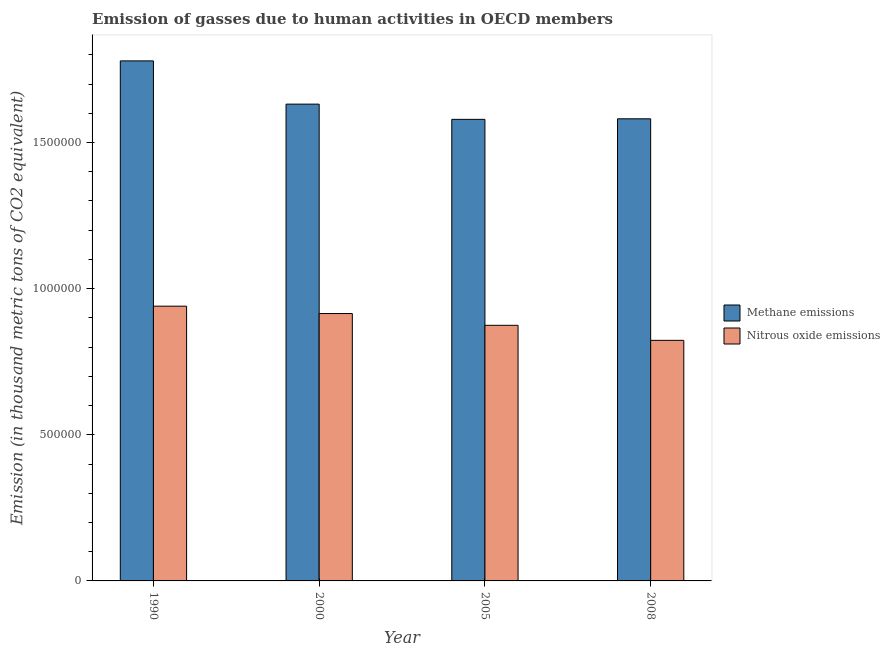How many groups of bars are there?
Provide a short and direct response. 4. Are the number of bars on each tick of the X-axis equal?
Ensure brevity in your answer.  Yes. How many bars are there on the 3rd tick from the left?
Offer a terse response. 2. How many bars are there on the 1st tick from the right?
Provide a succinct answer. 2. What is the amount of nitrous oxide emissions in 1990?
Offer a very short reply. 9.40e+05. Across all years, what is the maximum amount of nitrous oxide emissions?
Ensure brevity in your answer.  9.40e+05. Across all years, what is the minimum amount of nitrous oxide emissions?
Offer a terse response. 8.23e+05. In which year was the amount of methane emissions maximum?
Your response must be concise. 1990. In which year was the amount of methane emissions minimum?
Your answer should be compact. 2005. What is the total amount of methane emissions in the graph?
Offer a very short reply. 6.57e+06. What is the difference between the amount of nitrous oxide emissions in 1990 and that in 2008?
Your response must be concise. 1.17e+05. What is the difference between the amount of nitrous oxide emissions in 1990 and the amount of methane emissions in 2000?
Your response must be concise. 2.52e+04. What is the average amount of methane emissions per year?
Provide a succinct answer. 1.64e+06. In the year 1990, what is the difference between the amount of methane emissions and amount of nitrous oxide emissions?
Offer a terse response. 0. What is the ratio of the amount of nitrous oxide emissions in 1990 to that in 2005?
Give a very brief answer. 1.07. What is the difference between the highest and the second highest amount of nitrous oxide emissions?
Offer a terse response. 2.52e+04. What is the difference between the highest and the lowest amount of nitrous oxide emissions?
Provide a succinct answer. 1.17e+05. What does the 2nd bar from the left in 2005 represents?
Offer a very short reply. Nitrous oxide emissions. What does the 2nd bar from the right in 2008 represents?
Your response must be concise. Methane emissions. Are all the bars in the graph horizontal?
Keep it short and to the point. No. Are the values on the major ticks of Y-axis written in scientific E-notation?
Provide a short and direct response. No. Does the graph contain grids?
Provide a succinct answer. No. How are the legend labels stacked?
Give a very brief answer. Vertical. What is the title of the graph?
Provide a succinct answer. Emission of gasses due to human activities in OECD members. Does "Excluding technical cooperation" appear as one of the legend labels in the graph?
Keep it short and to the point. No. What is the label or title of the Y-axis?
Your answer should be very brief. Emission (in thousand metric tons of CO2 equivalent). What is the Emission (in thousand metric tons of CO2 equivalent) of Methane emissions in 1990?
Ensure brevity in your answer.  1.78e+06. What is the Emission (in thousand metric tons of CO2 equivalent) of Nitrous oxide emissions in 1990?
Make the answer very short. 9.40e+05. What is the Emission (in thousand metric tons of CO2 equivalent) in Methane emissions in 2000?
Give a very brief answer. 1.63e+06. What is the Emission (in thousand metric tons of CO2 equivalent) of Nitrous oxide emissions in 2000?
Make the answer very short. 9.15e+05. What is the Emission (in thousand metric tons of CO2 equivalent) in Methane emissions in 2005?
Offer a very short reply. 1.58e+06. What is the Emission (in thousand metric tons of CO2 equivalent) in Nitrous oxide emissions in 2005?
Your response must be concise. 8.75e+05. What is the Emission (in thousand metric tons of CO2 equivalent) of Methane emissions in 2008?
Make the answer very short. 1.58e+06. What is the Emission (in thousand metric tons of CO2 equivalent) of Nitrous oxide emissions in 2008?
Your answer should be very brief. 8.23e+05. Across all years, what is the maximum Emission (in thousand metric tons of CO2 equivalent) in Methane emissions?
Offer a very short reply. 1.78e+06. Across all years, what is the maximum Emission (in thousand metric tons of CO2 equivalent) in Nitrous oxide emissions?
Your answer should be compact. 9.40e+05. Across all years, what is the minimum Emission (in thousand metric tons of CO2 equivalent) of Methane emissions?
Ensure brevity in your answer.  1.58e+06. Across all years, what is the minimum Emission (in thousand metric tons of CO2 equivalent) in Nitrous oxide emissions?
Offer a very short reply. 8.23e+05. What is the total Emission (in thousand metric tons of CO2 equivalent) in Methane emissions in the graph?
Keep it short and to the point. 6.57e+06. What is the total Emission (in thousand metric tons of CO2 equivalent) of Nitrous oxide emissions in the graph?
Ensure brevity in your answer.  3.55e+06. What is the difference between the Emission (in thousand metric tons of CO2 equivalent) in Methane emissions in 1990 and that in 2000?
Keep it short and to the point. 1.48e+05. What is the difference between the Emission (in thousand metric tons of CO2 equivalent) in Nitrous oxide emissions in 1990 and that in 2000?
Your response must be concise. 2.52e+04. What is the difference between the Emission (in thousand metric tons of CO2 equivalent) of Methane emissions in 1990 and that in 2005?
Offer a very short reply. 2.00e+05. What is the difference between the Emission (in thousand metric tons of CO2 equivalent) of Nitrous oxide emissions in 1990 and that in 2005?
Your answer should be very brief. 6.55e+04. What is the difference between the Emission (in thousand metric tons of CO2 equivalent) in Methane emissions in 1990 and that in 2008?
Offer a very short reply. 1.98e+05. What is the difference between the Emission (in thousand metric tons of CO2 equivalent) in Nitrous oxide emissions in 1990 and that in 2008?
Ensure brevity in your answer.  1.17e+05. What is the difference between the Emission (in thousand metric tons of CO2 equivalent) of Methane emissions in 2000 and that in 2005?
Provide a succinct answer. 5.21e+04. What is the difference between the Emission (in thousand metric tons of CO2 equivalent) of Nitrous oxide emissions in 2000 and that in 2005?
Provide a succinct answer. 4.03e+04. What is the difference between the Emission (in thousand metric tons of CO2 equivalent) of Methane emissions in 2000 and that in 2008?
Offer a very short reply. 5.02e+04. What is the difference between the Emission (in thousand metric tons of CO2 equivalent) in Nitrous oxide emissions in 2000 and that in 2008?
Make the answer very short. 9.18e+04. What is the difference between the Emission (in thousand metric tons of CO2 equivalent) of Methane emissions in 2005 and that in 2008?
Provide a succinct answer. -1871.6. What is the difference between the Emission (in thousand metric tons of CO2 equivalent) of Nitrous oxide emissions in 2005 and that in 2008?
Your answer should be very brief. 5.15e+04. What is the difference between the Emission (in thousand metric tons of CO2 equivalent) in Methane emissions in 1990 and the Emission (in thousand metric tons of CO2 equivalent) in Nitrous oxide emissions in 2000?
Offer a terse response. 8.65e+05. What is the difference between the Emission (in thousand metric tons of CO2 equivalent) in Methane emissions in 1990 and the Emission (in thousand metric tons of CO2 equivalent) in Nitrous oxide emissions in 2005?
Ensure brevity in your answer.  9.05e+05. What is the difference between the Emission (in thousand metric tons of CO2 equivalent) in Methane emissions in 1990 and the Emission (in thousand metric tons of CO2 equivalent) in Nitrous oxide emissions in 2008?
Your answer should be very brief. 9.56e+05. What is the difference between the Emission (in thousand metric tons of CO2 equivalent) in Methane emissions in 2000 and the Emission (in thousand metric tons of CO2 equivalent) in Nitrous oxide emissions in 2005?
Give a very brief answer. 7.57e+05. What is the difference between the Emission (in thousand metric tons of CO2 equivalent) of Methane emissions in 2000 and the Emission (in thousand metric tons of CO2 equivalent) of Nitrous oxide emissions in 2008?
Your response must be concise. 8.08e+05. What is the difference between the Emission (in thousand metric tons of CO2 equivalent) in Methane emissions in 2005 and the Emission (in thousand metric tons of CO2 equivalent) in Nitrous oxide emissions in 2008?
Ensure brevity in your answer.  7.56e+05. What is the average Emission (in thousand metric tons of CO2 equivalent) of Methane emissions per year?
Make the answer very short. 1.64e+06. What is the average Emission (in thousand metric tons of CO2 equivalent) in Nitrous oxide emissions per year?
Provide a succinct answer. 8.88e+05. In the year 1990, what is the difference between the Emission (in thousand metric tons of CO2 equivalent) in Methane emissions and Emission (in thousand metric tons of CO2 equivalent) in Nitrous oxide emissions?
Make the answer very short. 8.39e+05. In the year 2000, what is the difference between the Emission (in thousand metric tons of CO2 equivalent) in Methane emissions and Emission (in thousand metric tons of CO2 equivalent) in Nitrous oxide emissions?
Provide a succinct answer. 7.17e+05. In the year 2005, what is the difference between the Emission (in thousand metric tons of CO2 equivalent) in Methane emissions and Emission (in thousand metric tons of CO2 equivalent) in Nitrous oxide emissions?
Provide a succinct answer. 7.05e+05. In the year 2008, what is the difference between the Emission (in thousand metric tons of CO2 equivalent) in Methane emissions and Emission (in thousand metric tons of CO2 equivalent) in Nitrous oxide emissions?
Make the answer very short. 7.58e+05. What is the ratio of the Emission (in thousand metric tons of CO2 equivalent) in Methane emissions in 1990 to that in 2000?
Offer a terse response. 1.09. What is the ratio of the Emission (in thousand metric tons of CO2 equivalent) in Nitrous oxide emissions in 1990 to that in 2000?
Offer a terse response. 1.03. What is the ratio of the Emission (in thousand metric tons of CO2 equivalent) in Methane emissions in 1990 to that in 2005?
Give a very brief answer. 1.13. What is the ratio of the Emission (in thousand metric tons of CO2 equivalent) in Nitrous oxide emissions in 1990 to that in 2005?
Provide a succinct answer. 1.07. What is the ratio of the Emission (in thousand metric tons of CO2 equivalent) in Methane emissions in 1990 to that in 2008?
Your response must be concise. 1.13. What is the ratio of the Emission (in thousand metric tons of CO2 equivalent) of Nitrous oxide emissions in 1990 to that in 2008?
Your response must be concise. 1.14. What is the ratio of the Emission (in thousand metric tons of CO2 equivalent) of Methane emissions in 2000 to that in 2005?
Offer a very short reply. 1.03. What is the ratio of the Emission (in thousand metric tons of CO2 equivalent) in Nitrous oxide emissions in 2000 to that in 2005?
Offer a terse response. 1.05. What is the ratio of the Emission (in thousand metric tons of CO2 equivalent) of Methane emissions in 2000 to that in 2008?
Your answer should be compact. 1.03. What is the ratio of the Emission (in thousand metric tons of CO2 equivalent) of Nitrous oxide emissions in 2000 to that in 2008?
Keep it short and to the point. 1.11. What is the ratio of the Emission (in thousand metric tons of CO2 equivalent) in Methane emissions in 2005 to that in 2008?
Provide a succinct answer. 1. What is the ratio of the Emission (in thousand metric tons of CO2 equivalent) of Nitrous oxide emissions in 2005 to that in 2008?
Your answer should be compact. 1.06. What is the difference between the highest and the second highest Emission (in thousand metric tons of CO2 equivalent) of Methane emissions?
Your answer should be very brief. 1.48e+05. What is the difference between the highest and the second highest Emission (in thousand metric tons of CO2 equivalent) of Nitrous oxide emissions?
Make the answer very short. 2.52e+04. What is the difference between the highest and the lowest Emission (in thousand metric tons of CO2 equivalent) of Methane emissions?
Your response must be concise. 2.00e+05. What is the difference between the highest and the lowest Emission (in thousand metric tons of CO2 equivalent) in Nitrous oxide emissions?
Give a very brief answer. 1.17e+05. 